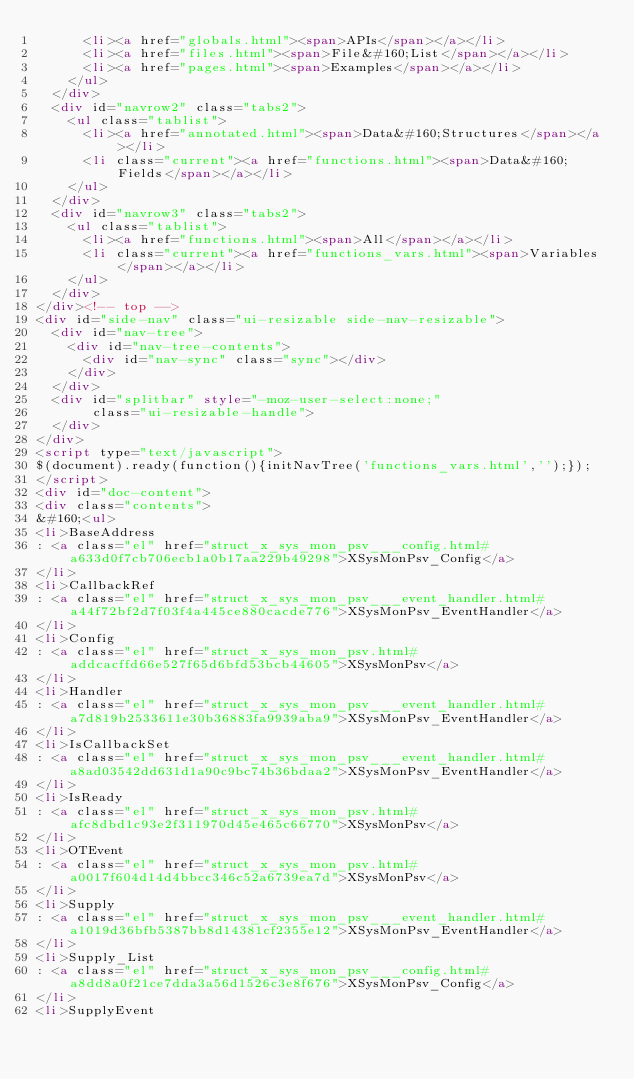Convert code to text. <code><loc_0><loc_0><loc_500><loc_500><_HTML_>      <li><a href="globals.html"><span>APIs</span></a></li>
      <li><a href="files.html"><span>File&#160;List</span></a></li>
      <li><a href="pages.html"><span>Examples</span></a></li>
    </ul>
  </div>
  <div id="navrow2" class="tabs2">
    <ul class="tablist">
      <li><a href="annotated.html"><span>Data&#160;Structures</span></a></li>
      <li class="current"><a href="functions.html"><span>Data&#160;Fields</span></a></li>
    </ul>
  </div>
  <div id="navrow3" class="tabs2">
    <ul class="tablist">
      <li><a href="functions.html"><span>All</span></a></li>
      <li class="current"><a href="functions_vars.html"><span>Variables</span></a></li>
    </ul>
  </div>
</div><!-- top -->
<div id="side-nav" class="ui-resizable side-nav-resizable">
  <div id="nav-tree">
    <div id="nav-tree-contents">
      <div id="nav-sync" class="sync"></div>
    </div>
  </div>
  <div id="splitbar" style="-moz-user-select:none;" 
       class="ui-resizable-handle">
  </div>
</div>
<script type="text/javascript">
$(document).ready(function(){initNavTree('functions_vars.html','');});
</script>
<div id="doc-content">
<div class="contents">
&#160;<ul>
<li>BaseAddress
: <a class="el" href="struct_x_sys_mon_psv___config.html#a633d0f7cb706ecb1a0b17aa229b49298">XSysMonPsv_Config</a>
</li>
<li>CallbackRef
: <a class="el" href="struct_x_sys_mon_psv___event_handler.html#a44f72bf2d7f03f4a445ce880cacde776">XSysMonPsv_EventHandler</a>
</li>
<li>Config
: <a class="el" href="struct_x_sys_mon_psv.html#addcacffd66e527f65d6bfd53bcb44605">XSysMonPsv</a>
</li>
<li>Handler
: <a class="el" href="struct_x_sys_mon_psv___event_handler.html#a7d819b2533611e30b36883fa9939aba9">XSysMonPsv_EventHandler</a>
</li>
<li>IsCallbackSet
: <a class="el" href="struct_x_sys_mon_psv___event_handler.html#a8ad03542dd631d1a90c9bc74b36bdaa2">XSysMonPsv_EventHandler</a>
</li>
<li>IsReady
: <a class="el" href="struct_x_sys_mon_psv.html#afc8dbd1c93e2f311970d45e465c66770">XSysMonPsv</a>
</li>
<li>OTEvent
: <a class="el" href="struct_x_sys_mon_psv.html#a0017f604d14d4bbcc346c52a6739ea7d">XSysMonPsv</a>
</li>
<li>Supply
: <a class="el" href="struct_x_sys_mon_psv___event_handler.html#a1019d36bfb5387bb8d14381cf2355e12">XSysMonPsv_EventHandler</a>
</li>
<li>Supply_List
: <a class="el" href="struct_x_sys_mon_psv___config.html#a8dd8a0f21ce7dda3a56d1526c3e8f676">XSysMonPsv_Config</a>
</li>
<li>SupplyEvent</code> 